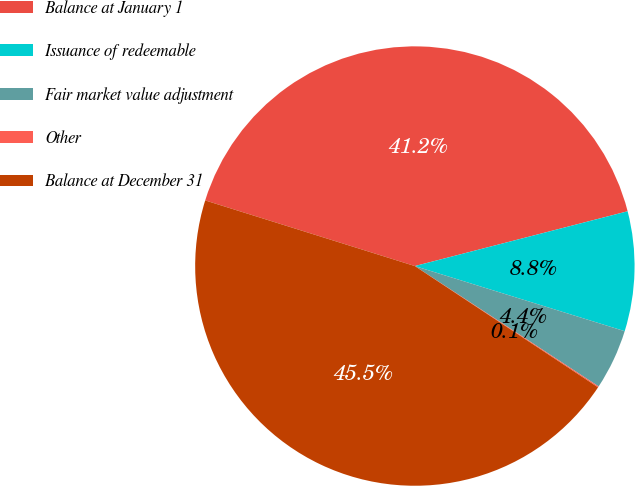Convert chart. <chart><loc_0><loc_0><loc_500><loc_500><pie_chart><fcel>Balance at January 1<fcel>Issuance of redeemable<fcel>Fair market value adjustment<fcel>Other<fcel>Balance at December 31<nl><fcel>41.16%<fcel>8.8%<fcel>4.44%<fcel>0.08%<fcel>45.52%<nl></chart> 